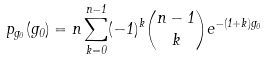<formula> <loc_0><loc_0><loc_500><loc_500>p _ { g _ { 0 } } ( g _ { 0 } ) = n \sum ^ { n - 1 } _ { k = 0 } ( - 1 ) ^ { k } \binom { n - 1 } { k } e ^ { - ( 1 + k ) g _ { 0 } }</formula> 